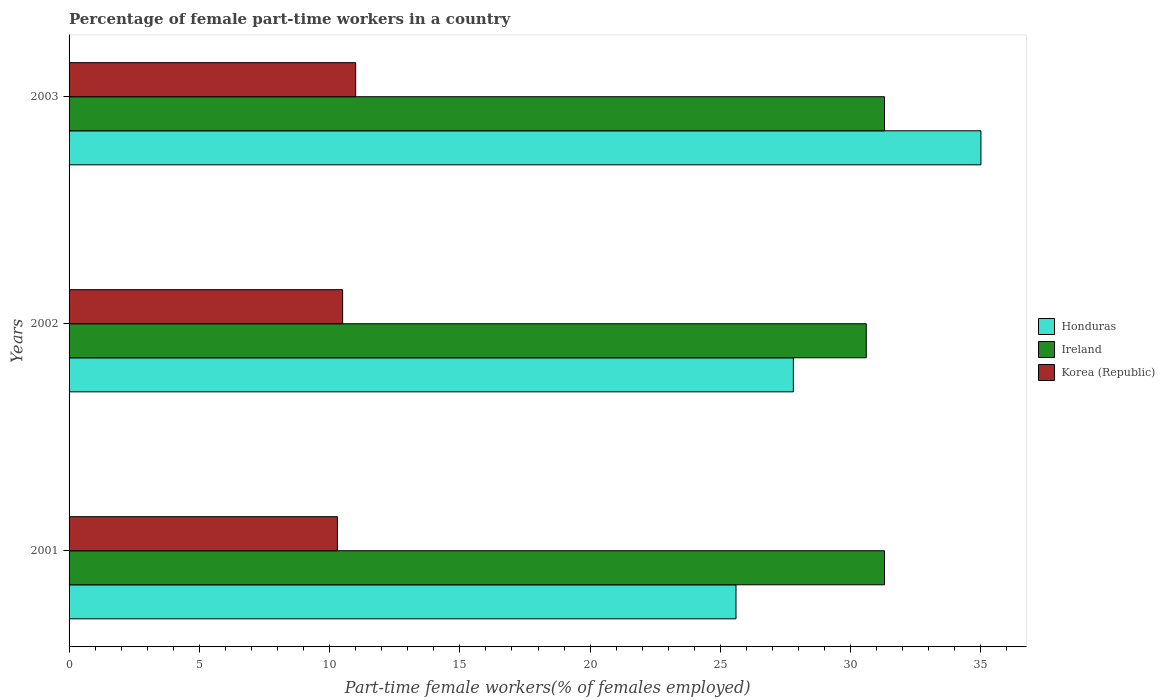How many different coloured bars are there?
Offer a terse response. 3. How many groups of bars are there?
Offer a very short reply. 3. Are the number of bars per tick equal to the number of legend labels?
Your answer should be very brief. Yes. Are the number of bars on each tick of the Y-axis equal?
Make the answer very short. Yes. How many bars are there on the 1st tick from the top?
Offer a very short reply. 3. What is the label of the 1st group of bars from the top?
Provide a short and direct response. 2003. In how many cases, is the number of bars for a given year not equal to the number of legend labels?
Offer a very short reply. 0. What is the percentage of female part-time workers in Honduras in 2001?
Make the answer very short. 25.6. Across all years, what is the maximum percentage of female part-time workers in Honduras?
Offer a terse response. 35. Across all years, what is the minimum percentage of female part-time workers in Korea (Republic)?
Make the answer very short. 10.3. What is the total percentage of female part-time workers in Ireland in the graph?
Make the answer very short. 93.2. What is the difference between the percentage of female part-time workers in Honduras in 2001 and the percentage of female part-time workers in Korea (Republic) in 2003?
Give a very brief answer. 14.6. What is the average percentage of female part-time workers in Honduras per year?
Your answer should be very brief. 29.47. In the year 2001, what is the difference between the percentage of female part-time workers in Ireland and percentage of female part-time workers in Korea (Republic)?
Provide a short and direct response. 21. In how many years, is the percentage of female part-time workers in Honduras greater than 21 %?
Offer a very short reply. 3. What is the ratio of the percentage of female part-time workers in Korea (Republic) in 2001 to that in 2002?
Keep it short and to the point. 0.98. What is the difference between the highest and the second highest percentage of female part-time workers in Ireland?
Make the answer very short. 0. What is the difference between the highest and the lowest percentage of female part-time workers in Honduras?
Offer a terse response. 9.4. What does the 3rd bar from the top in 2001 represents?
Offer a terse response. Honduras. What does the 2nd bar from the bottom in 2001 represents?
Give a very brief answer. Ireland. Are the values on the major ticks of X-axis written in scientific E-notation?
Give a very brief answer. No. Does the graph contain grids?
Ensure brevity in your answer.  No. What is the title of the graph?
Provide a short and direct response. Percentage of female part-time workers in a country. What is the label or title of the X-axis?
Offer a very short reply. Part-time female workers(% of females employed). What is the Part-time female workers(% of females employed) in Honduras in 2001?
Your answer should be very brief. 25.6. What is the Part-time female workers(% of females employed) in Ireland in 2001?
Make the answer very short. 31.3. What is the Part-time female workers(% of females employed) in Korea (Republic) in 2001?
Your answer should be compact. 10.3. What is the Part-time female workers(% of females employed) in Honduras in 2002?
Provide a short and direct response. 27.8. What is the Part-time female workers(% of females employed) in Ireland in 2002?
Provide a succinct answer. 30.6. What is the Part-time female workers(% of females employed) of Honduras in 2003?
Offer a very short reply. 35. What is the Part-time female workers(% of females employed) in Ireland in 2003?
Ensure brevity in your answer.  31.3. What is the Part-time female workers(% of females employed) in Korea (Republic) in 2003?
Your response must be concise. 11. Across all years, what is the maximum Part-time female workers(% of females employed) in Honduras?
Offer a very short reply. 35. Across all years, what is the maximum Part-time female workers(% of females employed) in Ireland?
Keep it short and to the point. 31.3. Across all years, what is the minimum Part-time female workers(% of females employed) of Honduras?
Give a very brief answer. 25.6. Across all years, what is the minimum Part-time female workers(% of females employed) of Ireland?
Your response must be concise. 30.6. Across all years, what is the minimum Part-time female workers(% of females employed) in Korea (Republic)?
Make the answer very short. 10.3. What is the total Part-time female workers(% of females employed) of Honduras in the graph?
Offer a very short reply. 88.4. What is the total Part-time female workers(% of females employed) in Ireland in the graph?
Offer a very short reply. 93.2. What is the total Part-time female workers(% of females employed) in Korea (Republic) in the graph?
Provide a succinct answer. 31.8. What is the difference between the Part-time female workers(% of females employed) in Korea (Republic) in 2001 and that in 2002?
Your answer should be compact. -0.2. What is the difference between the Part-time female workers(% of females employed) of Korea (Republic) in 2001 and that in 2003?
Provide a short and direct response. -0.7. What is the difference between the Part-time female workers(% of females employed) in Honduras in 2002 and that in 2003?
Your answer should be very brief. -7.2. What is the difference between the Part-time female workers(% of females employed) of Ireland in 2002 and that in 2003?
Your response must be concise. -0.7. What is the difference between the Part-time female workers(% of females employed) of Honduras in 2001 and the Part-time female workers(% of females employed) of Ireland in 2002?
Ensure brevity in your answer.  -5. What is the difference between the Part-time female workers(% of females employed) of Honduras in 2001 and the Part-time female workers(% of females employed) of Korea (Republic) in 2002?
Your answer should be compact. 15.1. What is the difference between the Part-time female workers(% of females employed) in Ireland in 2001 and the Part-time female workers(% of females employed) in Korea (Republic) in 2002?
Provide a short and direct response. 20.8. What is the difference between the Part-time female workers(% of females employed) of Honduras in 2001 and the Part-time female workers(% of females employed) of Korea (Republic) in 2003?
Your answer should be very brief. 14.6. What is the difference between the Part-time female workers(% of females employed) in Ireland in 2001 and the Part-time female workers(% of females employed) in Korea (Republic) in 2003?
Offer a terse response. 20.3. What is the difference between the Part-time female workers(% of females employed) in Honduras in 2002 and the Part-time female workers(% of females employed) in Ireland in 2003?
Provide a succinct answer. -3.5. What is the difference between the Part-time female workers(% of females employed) in Honduras in 2002 and the Part-time female workers(% of females employed) in Korea (Republic) in 2003?
Offer a terse response. 16.8. What is the difference between the Part-time female workers(% of females employed) in Ireland in 2002 and the Part-time female workers(% of females employed) in Korea (Republic) in 2003?
Your answer should be compact. 19.6. What is the average Part-time female workers(% of females employed) of Honduras per year?
Ensure brevity in your answer.  29.47. What is the average Part-time female workers(% of females employed) in Ireland per year?
Make the answer very short. 31.07. What is the average Part-time female workers(% of females employed) in Korea (Republic) per year?
Offer a terse response. 10.6. In the year 2002, what is the difference between the Part-time female workers(% of females employed) in Honduras and Part-time female workers(% of females employed) in Ireland?
Offer a very short reply. -2.8. In the year 2002, what is the difference between the Part-time female workers(% of females employed) in Ireland and Part-time female workers(% of females employed) in Korea (Republic)?
Provide a short and direct response. 20.1. In the year 2003, what is the difference between the Part-time female workers(% of females employed) in Honduras and Part-time female workers(% of females employed) in Ireland?
Make the answer very short. 3.7. In the year 2003, what is the difference between the Part-time female workers(% of females employed) in Honduras and Part-time female workers(% of females employed) in Korea (Republic)?
Keep it short and to the point. 24. In the year 2003, what is the difference between the Part-time female workers(% of females employed) of Ireland and Part-time female workers(% of females employed) of Korea (Republic)?
Your response must be concise. 20.3. What is the ratio of the Part-time female workers(% of females employed) in Honduras in 2001 to that in 2002?
Provide a short and direct response. 0.92. What is the ratio of the Part-time female workers(% of females employed) of Ireland in 2001 to that in 2002?
Offer a very short reply. 1.02. What is the ratio of the Part-time female workers(% of females employed) in Korea (Republic) in 2001 to that in 2002?
Offer a very short reply. 0.98. What is the ratio of the Part-time female workers(% of females employed) of Honduras in 2001 to that in 2003?
Your answer should be compact. 0.73. What is the ratio of the Part-time female workers(% of females employed) of Korea (Republic) in 2001 to that in 2003?
Give a very brief answer. 0.94. What is the ratio of the Part-time female workers(% of females employed) of Honduras in 2002 to that in 2003?
Give a very brief answer. 0.79. What is the ratio of the Part-time female workers(% of females employed) of Ireland in 2002 to that in 2003?
Offer a very short reply. 0.98. What is the ratio of the Part-time female workers(% of females employed) of Korea (Republic) in 2002 to that in 2003?
Your answer should be very brief. 0.95. What is the difference between the highest and the second highest Part-time female workers(% of females employed) in Honduras?
Give a very brief answer. 7.2. What is the difference between the highest and the lowest Part-time female workers(% of females employed) in Honduras?
Make the answer very short. 9.4. What is the difference between the highest and the lowest Part-time female workers(% of females employed) of Ireland?
Your response must be concise. 0.7. What is the difference between the highest and the lowest Part-time female workers(% of females employed) in Korea (Republic)?
Your answer should be very brief. 0.7. 